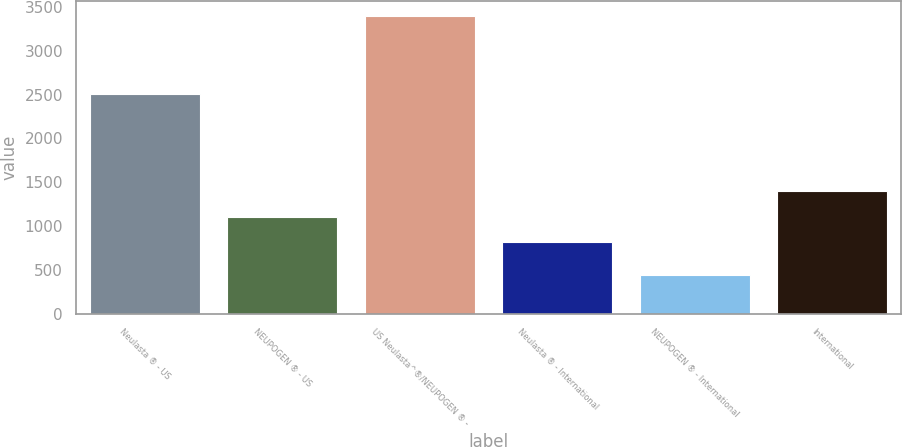<chart> <loc_0><loc_0><loc_500><loc_500><bar_chart><fcel>Neulasta ® - US<fcel>NEUPOGEN ® - US<fcel>US Neulasta^®/NEUPOGEN ® -<fcel>Neulasta ® - International<fcel>NEUPOGEN ® - International<fcel>International<nl><fcel>2505<fcel>1108.6<fcel>3401<fcel>813<fcel>445<fcel>1404.2<nl></chart> 